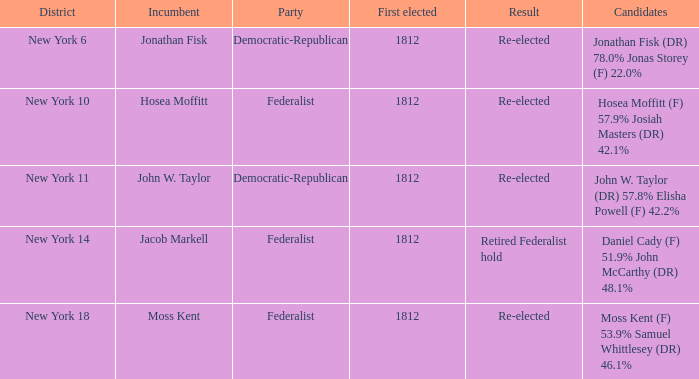Who currently occupies the position for new york's 10th district in congress? Hosea Moffitt. 